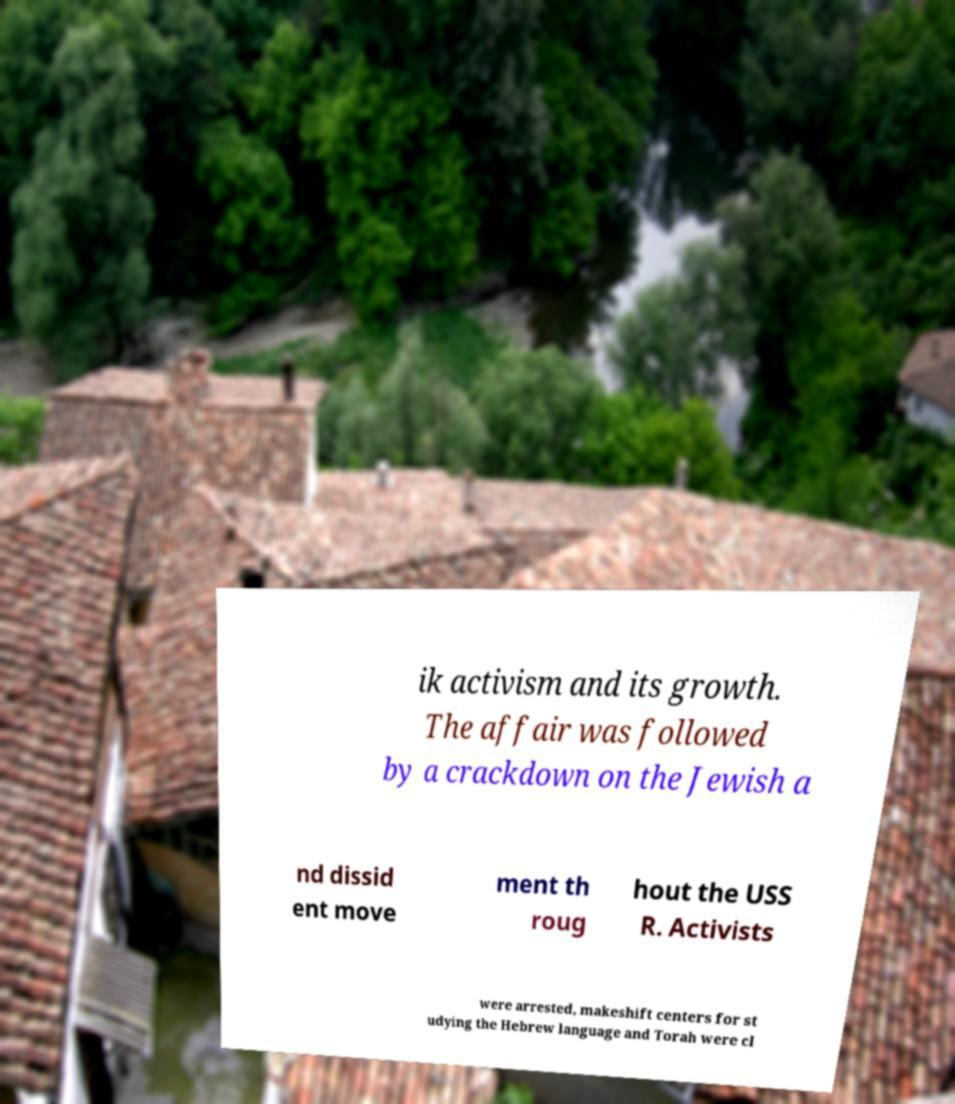Can you accurately transcribe the text from the provided image for me? ik activism and its growth. The affair was followed by a crackdown on the Jewish a nd dissid ent move ment th roug hout the USS R. Activists were arrested, makeshift centers for st udying the Hebrew language and Torah were cl 